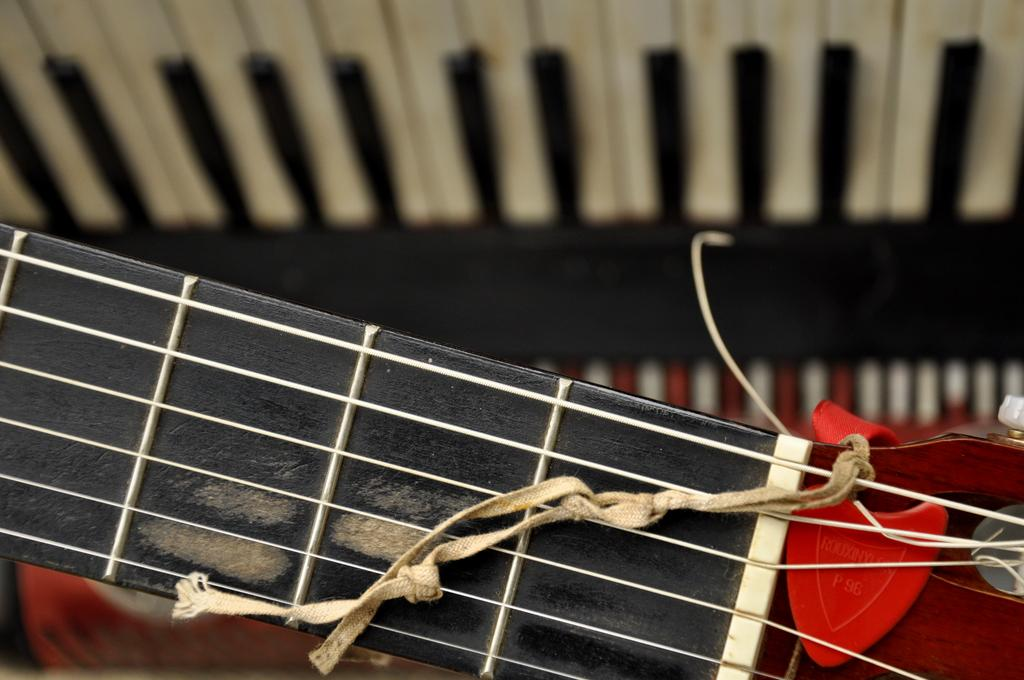What objects can be seen in the image? There are musical instruments in the image. Can you describe any specific details about the musical instruments? Yes, there is a thread on top of one of the musical instruments. Can you tell me how many horses are playing the musical instruments in the image? There are no horses present in the image; it features musical instruments with a thread on one of them. Is there a fireman in the image helping to play the musical instruments? There is no fireman present in the image; it only features musical instruments with a thread on one of them. 